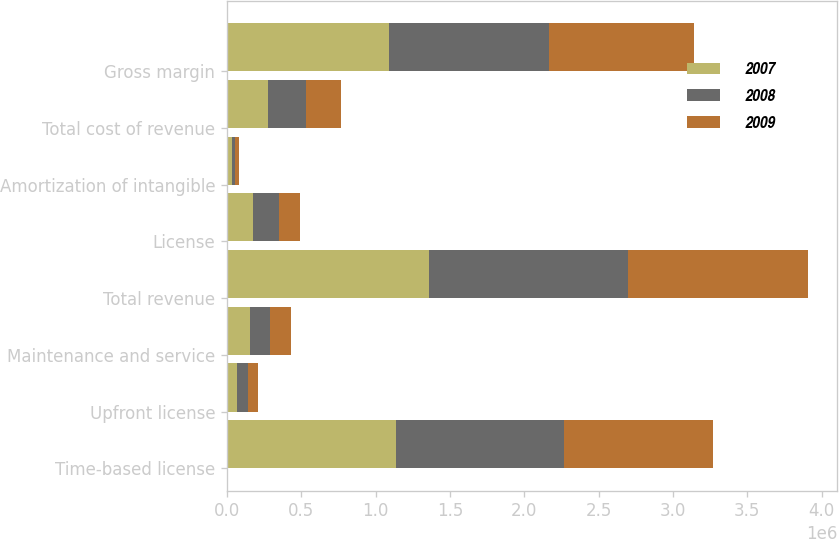<chart> <loc_0><loc_0><loc_500><loc_500><stacked_bar_chart><ecel><fcel>Time-based license<fcel>Upfront license<fcel>Maintenance and service<fcel>Total revenue<fcel>License<fcel>Amortization of intangible<fcel>Total cost of revenue<fcel>Gross margin<nl><fcel>2007<fcel>1.13855e+06<fcel>69473<fcel>152021<fcel>1.36004e+06<fcel>175620<fcel>32662<fcel>273650<fcel>1.0864e+06<nl><fcel>2008<fcel>1.12584e+06<fcel>71383<fcel>139723<fcel>1.33695e+06<fcel>171974<fcel>23326<fcel>258896<fcel>1.07806e+06<nl><fcel>2009<fcel>1.00403e+06<fcel>67524<fcel>140919<fcel>1.21247e+06<fcel>146420<fcel>23487<fcel>234265<fcel>978204<nl></chart> 